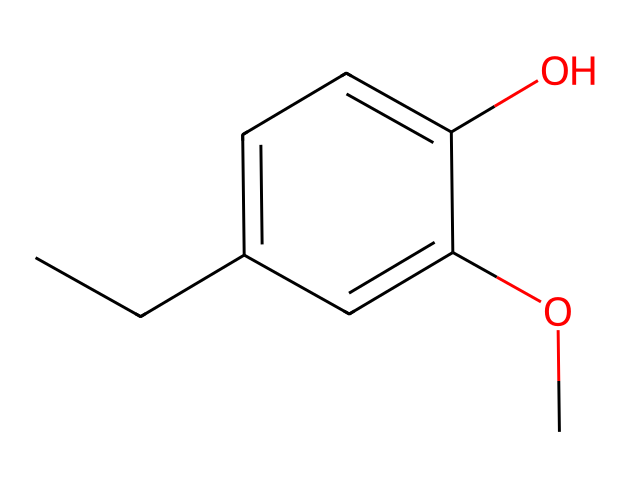What type of chemical is eugenol? Based on the SMILES representation and structure, eugenol is classified as a phenol because it contains a hydroxyl group (-OH) attached to an aromatic ring.
Answer: phenol How many carbon atoms are in eugenol? By analyzing the SMILES structure, there are a total of 10 carbon atoms present in the chemical composition of eugenol.
Answer: 10 What functional groups are present in eugenol? The SMILES representation shows both a hydroxyl group (-OH) and a methoxy group (-OCH3), which are the functional groups present in eugenol.
Answer: hydroxyl and methoxy What is the molecular formula of eugenol? By counting the atoms from the SMILES structure, the molecular formula deduced from the analysis is C10H12O3.
Answer: C10H12O3 What kind of interaction does the hydroxyl group in eugenol promote? The hydroxyl group in phenols, like in eugenol, promotes hydrogen bonding due to its ability to donate a hydrogen atom to nearby electronegative atoms, commonly seen in water solubility contexts.
Answer: hydrogen bonding Which property of eugenol contributes to its use in dentistry? The phenolic structure of eugenol allows it to exhibit antimicrobial properties, which is a significant factor in its use for dental applications.
Answer: antimicrobial properties 